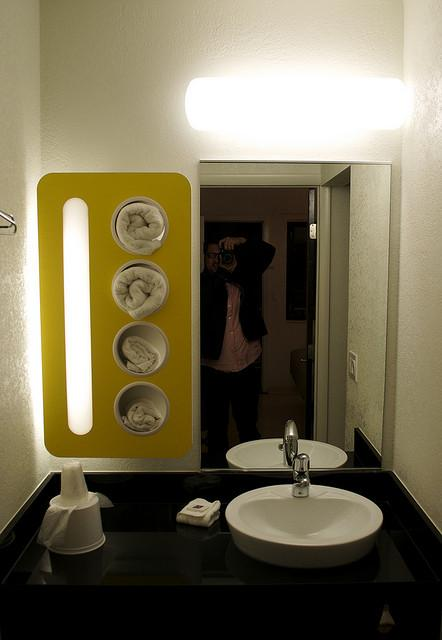What is near the sink?

Choices:
A) towel
B) badger
C) baby
D) cat towel 